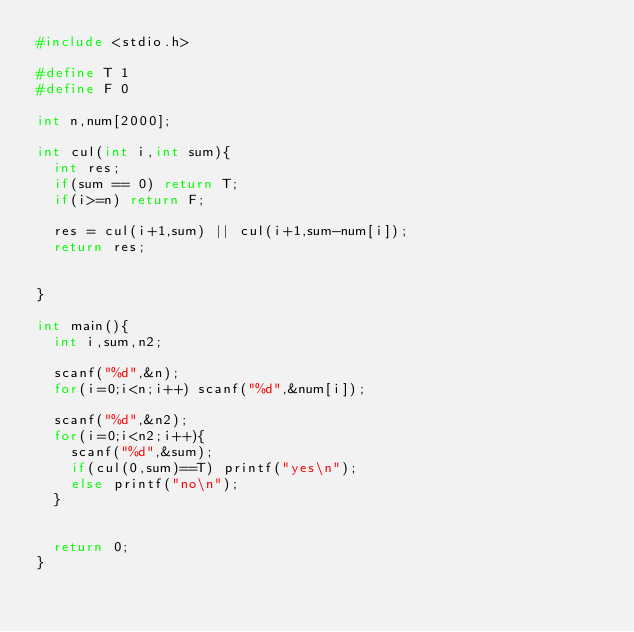<code> <loc_0><loc_0><loc_500><loc_500><_C_>#include <stdio.h>

#define T 1
#define F 0

int n,num[2000];

int cul(int i,int sum){
  int res;
  if(sum == 0) return T;
  if(i>=n) return F;
  
  res = cul(i+1,sum) || cul(i+1,sum-num[i]);
  return res;
  

}

int main(){
  int i,sum,n2;

  scanf("%d",&n);
  for(i=0;i<n;i++) scanf("%d",&num[i]);

  scanf("%d",&n2);
  for(i=0;i<n2;i++){
    scanf("%d",&sum);
    if(cul(0,sum)==T) printf("yes\n");
    else printf("no\n");
  }
  

  return 0;
}</code> 